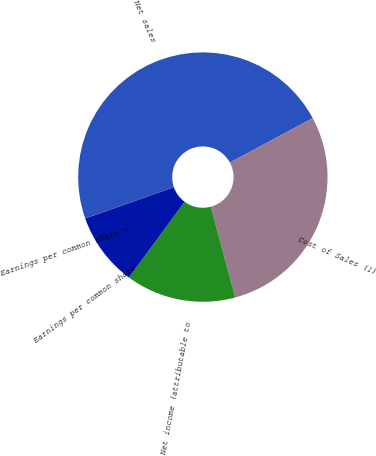<chart> <loc_0><loc_0><loc_500><loc_500><pie_chart><fcel>Net sales<fcel>Cost of Sales (1)<fcel>Net income (attributable to<fcel>Earnings per common share<fcel>Earnings per common share -<nl><fcel>47.53%<fcel>28.66%<fcel>14.27%<fcel>9.52%<fcel>0.02%<nl></chart> 